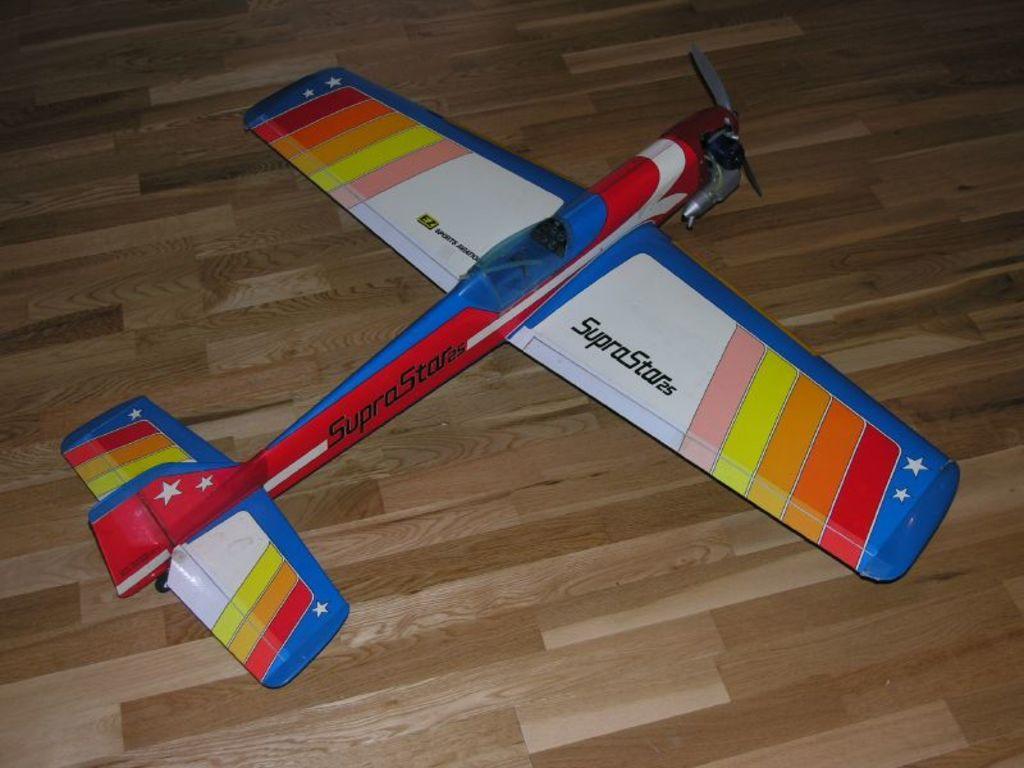Can you describe this image briefly? In this image we can see a toy plane which is placed on the wooden surface. 